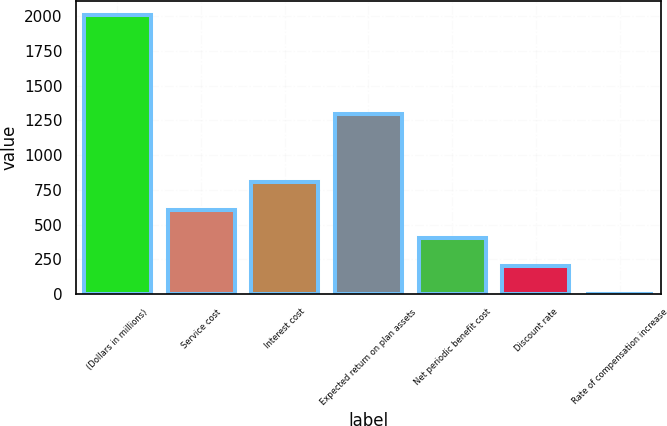Convert chart. <chart><loc_0><loc_0><loc_500><loc_500><bar_chart><fcel>(Dollars in millions)<fcel>Service cost<fcel>Interest cost<fcel>Expected return on plan assets<fcel>Net periodic benefit cost<fcel>Discount rate<fcel>Rate of compensation increase<nl><fcel>2011<fcel>606.1<fcel>806.8<fcel>1296<fcel>405.4<fcel>204.7<fcel>4<nl></chart> 